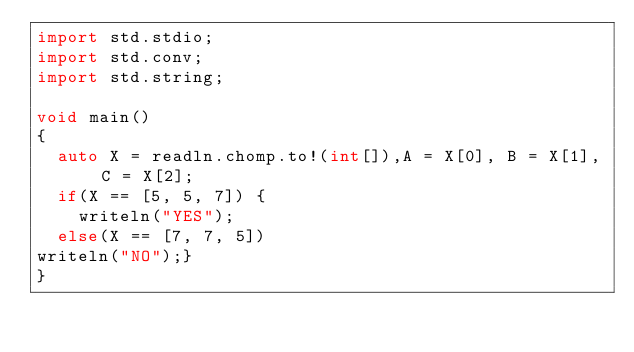Convert code to text. <code><loc_0><loc_0><loc_500><loc_500><_D_>import std.stdio;
import std.conv;
import std.string;

void main()
{
	auto X = readln.chomp.to!(int[]),A = X[0], B = X[1], C = X[2];
	if(X == [5, 5, 7]) {
		writeln("YES");
	else(X == [7, 7, 5])
writeln("NO");}
}</code> 